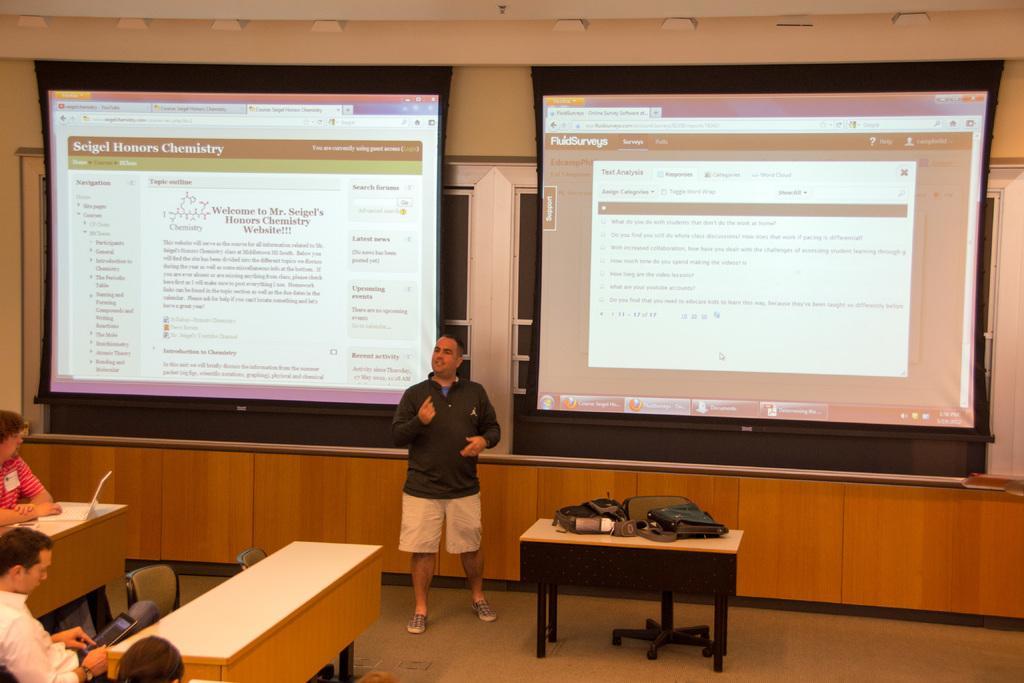How would you summarize this image in a sentence or two? In the middle of this image I can see a man standing and speaking something. At the back of this person there are two screens. On the left side of the image there are some people sitting on the chairs. In the middle of the image there is a table and on that on bag is there. 